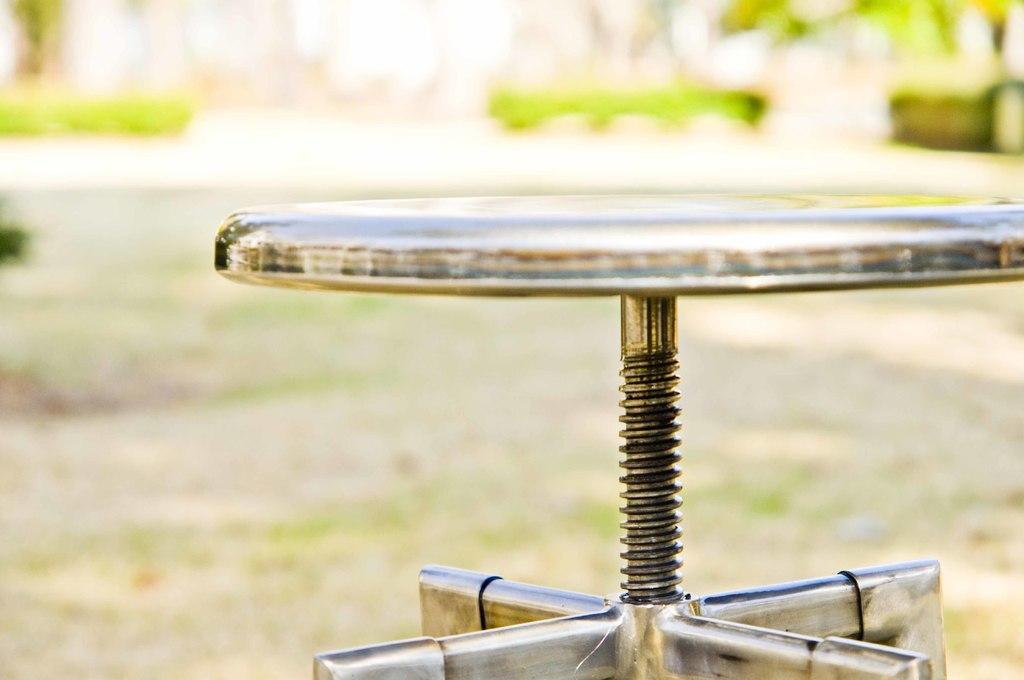Describe this image in one or two sentences. This image is taken outdoors. In this image the background is a little blurred. There are a few trees and plants. At the bottom of the image there is a ground. On the right side of the image there is a stool on the ground. 